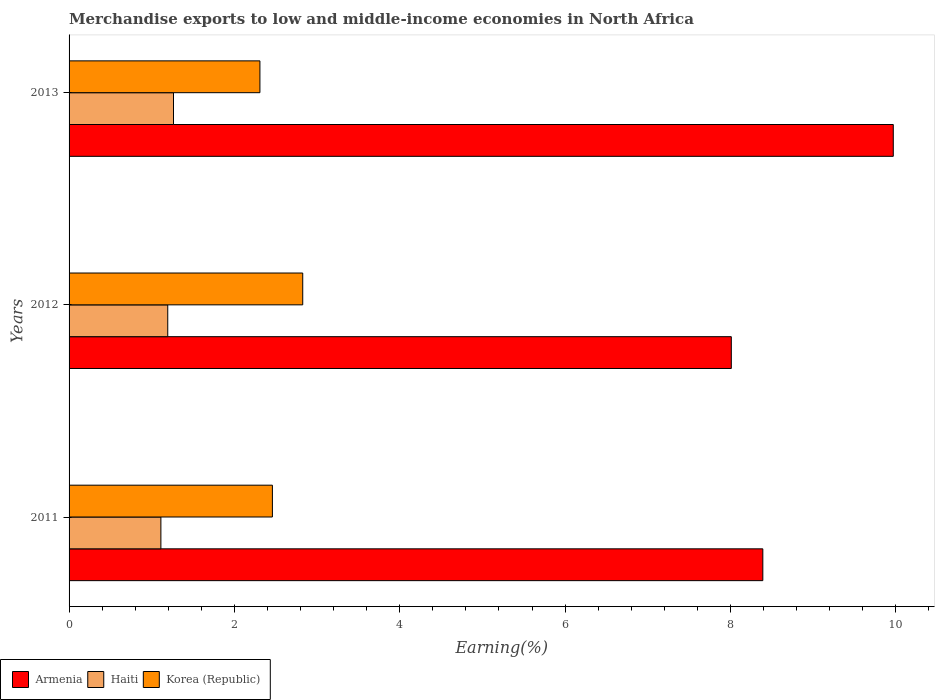Are the number of bars per tick equal to the number of legend labels?
Give a very brief answer. Yes. How many bars are there on the 1st tick from the top?
Ensure brevity in your answer.  3. What is the label of the 3rd group of bars from the top?
Make the answer very short. 2011. What is the percentage of amount earned from merchandise exports in Armenia in 2011?
Provide a succinct answer. 8.39. Across all years, what is the maximum percentage of amount earned from merchandise exports in Korea (Republic)?
Your answer should be very brief. 2.83. Across all years, what is the minimum percentage of amount earned from merchandise exports in Armenia?
Your answer should be very brief. 8.01. In which year was the percentage of amount earned from merchandise exports in Armenia maximum?
Your answer should be compact. 2013. In which year was the percentage of amount earned from merchandise exports in Haiti minimum?
Provide a succinct answer. 2011. What is the total percentage of amount earned from merchandise exports in Haiti in the graph?
Ensure brevity in your answer.  3.57. What is the difference between the percentage of amount earned from merchandise exports in Haiti in 2011 and that in 2012?
Ensure brevity in your answer.  -0.08. What is the difference between the percentage of amount earned from merchandise exports in Korea (Republic) in 2013 and the percentage of amount earned from merchandise exports in Armenia in 2012?
Your response must be concise. -5.7. What is the average percentage of amount earned from merchandise exports in Armenia per year?
Provide a succinct answer. 8.79. In the year 2011, what is the difference between the percentage of amount earned from merchandise exports in Armenia and percentage of amount earned from merchandise exports in Haiti?
Provide a succinct answer. 7.28. What is the ratio of the percentage of amount earned from merchandise exports in Korea (Republic) in 2011 to that in 2013?
Give a very brief answer. 1.07. Is the percentage of amount earned from merchandise exports in Haiti in 2011 less than that in 2012?
Offer a terse response. Yes. What is the difference between the highest and the second highest percentage of amount earned from merchandise exports in Haiti?
Your response must be concise. 0.07. What is the difference between the highest and the lowest percentage of amount earned from merchandise exports in Armenia?
Offer a very short reply. 1.96. In how many years, is the percentage of amount earned from merchandise exports in Armenia greater than the average percentage of amount earned from merchandise exports in Armenia taken over all years?
Keep it short and to the point. 1. What does the 3rd bar from the top in 2011 represents?
Offer a terse response. Armenia. What does the 3rd bar from the bottom in 2013 represents?
Keep it short and to the point. Korea (Republic). How many bars are there?
Your answer should be very brief. 9. How many years are there in the graph?
Offer a terse response. 3. What is the difference between two consecutive major ticks on the X-axis?
Give a very brief answer. 2. Where does the legend appear in the graph?
Make the answer very short. Bottom left. What is the title of the graph?
Make the answer very short. Merchandise exports to low and middle-income economies in North Africa. Does "Angola" appear as one of the legend labels in the graph?
Offer a very short reply. No. What is the label or title of the X-axis?
Your answer should be very brief. Earning(%). What is the Earning(%) in Armenia in 2011?
Give a very brief answer. 8.39. What is the Earning(%) in Haiti in 2011?
Your answer should be compact. 1.11. What is the Earning(%) of Korea (Republic) in 2011?
Your answer should be very brief. 2.46. What is the Earning(%) in Armenia in 2012?
Offer a very short reply. 8.01. What is the Earning(%) of Haiti in 2012?
Ensure brevity in your answer.  1.19. What is the Earning(%) of Korea (Republic) in 2012?
Your response must be concise. 2.83. What is the Earning(%) of Armenia in 2013?
Give a very brief answer. 9.97. What is the Earning(%) in Haiti in 2013?
Provide a short and direct response. 1.26. What is the Earning(%) of Korea (Republic) in 2013?
Your response must be concise. 2.31. Across all years, what is the maximum Earning(%) of Armenia?
Your answer should be very brief. 9.97. Across all years, what is the maximum Earning(%) in Haiti?
Provide a short and direct response. 1.26. Across all years, what is the maximum Earning(%) in Korea (Republic)?
Your answer should be very brief. 2.83. Across all years, what is the minimum Earning(%) of Armenia?
Offer a terse response. 8.01. Across all years, what is the minimum Earning(%) of Haiti?
Your answer should be compact. 1.11. Across all years, what is the minimum Earning(%) in Korea (Republic)?
Offer a terse response. 2.31. What is the total Earning(%) in Armenia in the graph?
Give a very brief answer. 26.37. What is the total Earning(%) of Haiti in the graph?
Your response must be concise. 3.57. What is the total Earning(%) in Korea (Republic) in the graph?
Ensure brevity in your answer.  7.59. What is the difference between the Earning(%) of Armenia in 2011 and that in 2012?
Provide a short and direct response. 0.38. What is the difference between the Earning(%) of Haiti in 2011 and that in 2012?
Provide a succinct answer. -0.08. What is the difference between the Earning(%) in Korea (Republic) in 2011 and that in 2012?
Ensure brevity in your answer.  -0.37. What is the difference between the Earning(%) of Armenia in 2011 and that in 2013?
Provide a short and direct response. -1.58. What is the difference between the Earning(%) in Haiti in 2011 and that in 2013?
Your response must be concise. -0.15. What is the difference between the Earning(%) of Korea (Republic) in 2011 and that in 2013?
Provide a succinct answer. 0.15. What is the difference between the Earning(%) of Armenia in 2012 and that in 2013?
Offer a terse response. -1.96. What is the difference between the Earning(%) of Haiti in 2012 and that in 2013?
Offer a very short reply. -0.07. What is the difference between the Earning(%) in Korea (Republic) in 2012 and that in 2013?
Make the answer very short. 0.52. What is the difference between the Earning(%) in Armenia in 2011 and the Earning(%) in Haiti in 2012?
Offer a terse response. 7.2. What is the difference between the Earning(%) in Armenia in 2011 and the Earning(%) in Korea (Republic) in 2012?
Offer a terse response. 5.57. What is the difference between the Earning(%) of Haiti in 2011 and the Earning(%) of Korea (Republic) in 2012?
Provide a short and direct response. -1.72. What is the difference between the Earning(%) in Armenia in 2011 and the Earning(%) in Haiti in 2013?
Give a very brief answer. 7.13. What is the difference between the Earning(%) of Armenia in 2011 and the Earning(%) of Korea (Republic) in 2013?
Your answer should be very brief. 6.08. What is the difference between the Earning(%) of Haiti in 2011 and the Earning(%) of Korea (Republic) in 2013?
Keep it short and to the point. -1.2. What is the difference between the Earning(%) of Armenia in 2012 and the Earning(%) of Haiti in 2013?
Your response must be concise. 6.75. What is the difference between the Earning(%) of Armenia in 2012 and the Earning(%) of Korea (Republic) in 2013?
Your response must be concise. 5.7. What is the difference between the Earning(%) in Haiti in 2012 and the Earning(%) in Korea (Republic) in 2013?
Offer a very short reply. -1.11. What is the average Earning(%) in Armenia per year?
Your response must be concise. 8.79. What is the average Earning(%) of Haiti per year?
Provide a short and direct response. 1.19. What is the average Earning(%) in Korea (Republic) per year?
Give a very brief answer. 2.53. In the year 2011, what is the difference between the Earning(%) of Armenia and Earning(%) of Haiti?
Ensure brevity in your answer.  7.28. In the year 2011, what is the difference between the Earning(%) in Armenia and Earning(%) in Korea (Republic)?
Offer a very short reply. 5.93. In the year 2011, what is the difference between the Earning(%) in Haiti and Earning(%) in Korea (Republic)?
Offer a terse response. -1.35. In the year 2012, what is the difference between the Earning(%) of Armenia and Earning(%) of Haiti?
Your answer should be very brief. 6.82. In the year 2012, what is the difference between the Earning(%) in Armenia and Earning(%) in Korea (Republic)?
Your response must be concise. 5.18. In the year 2012, what is the difference between the Earning(%) in Haiti and Earning(%) in Korea (Republic)?
Provide a succinct answer. -1.63. In the year 2013, what is the difference between the Earning(%) of Armenia and Earning(%) of Haiti?
Your response must be concise. 8.71. In the year 2013, what is the difference between the Earning(%) of Armenia and Earning(%) of Korea (Republic)?
Provide a short and direct response. 7.66. In the year 2013, what is the difference between the Earning(%) in Haiti and Earning(%) in Korea (Republic)?
Provide a short and direct response. -1.05. What is the ratio of the Earning(%) of Armenia in 2011 to that in 2012?
Provide a succinct answer. 1.05. What is the ratio of the Earning(%) in Haiti in 2011 to that in 2012?
Keep it short and to the point. 0.93. What is the ratio of the Earning(%) of Korea (Republic) in 2011 to that in 2012?
Offer a very short reply. 0.87. What is the ratio of the Earning(%) in Armenia in 2011 to that in 2013?
Your answer should be compact. 0.84. What is the ratio of the Earning(%) in Haiti in 2011 to that in 2013?
Ensure brevity in your answer.  0.88. What is the ratio of the Earning(%) in Korea (Republic) in 2011 to that in 2013?
Your answer should be compact. 1.07. What is the ratio of the Earning(%) of Armenia in 2012 to that in 2013?
Your response must be concise. 0.8. What is the ratio of the Earning(%) of Haiti in 2012 to that in 2013?
Your answer should be very brief. 0.94. What is the ratio of the Earning(%) in Korea (Republic) in 2012 to that in 2013?
Offer a very short reply. 1.22. What is the difference between the highest and the second highest Earning(%) in Armenia?
Offer a terse response. 1.58. What is the difference between the highest and the second highest Earning(%) in Haiti?
Offer a terse response. 0.07. What is the difference between the highest and the second highest Earning(%) of Korea (Republic)?
Offer a very short reply. 0.37. What is the difference between the highest and the lowest Earning(%) in Armenia?
Ensure brevity in your answer.  1.96. What is the difference between the highest and the lowest Earning(%) in Haiti?
Give a very brief answer. 0.15. What is the difference between the highest and the lowest Earning(%) in Korea (Republic)?
Keep it short and to the point. 0.52. 